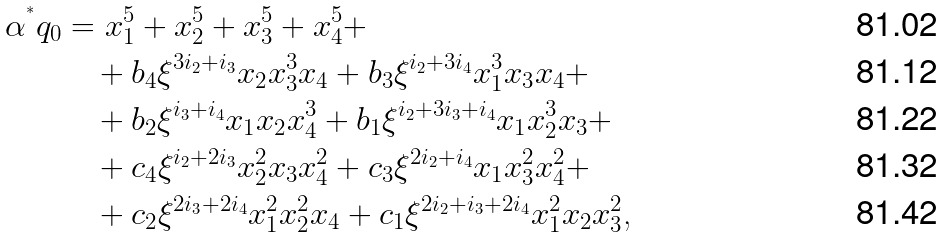Convert formula to latex. <formula><loc_0><loc_0><loc_500><loc_500>\alpha ^ { ^ { * } } q _ { 0 } & = x _ { 1 } ^ { 5 } + x _ { 2 } ^ { 5 } + x _ { 3 } ^ { 5 } + x _ { 4 } ^ { 5 } + \\ & \quad + b _ { 4 } \xi ^ { 3 i _ { 2 } + i _ { 3 } } x _ { 2 } x _ { 3 } ^ { 3 } x _ { 4 } + b _ { 3 } \xi ^ { i _ { 2 } + 3 i _ { 4 } } x _ { 1 } ^ { 3 } x _ { 3 } x _ { 4 } + \\ & \quad + b _ { 2 } \xi ^ { i _ { 3 } + i _ { 4 } } x _ { 1 } x _ { 2 } x _ { 4 } ^ { 3 } + b _ { 1 } \xi ^ { i _ { 2 } + 3 i _ { 3 } + i _ { 4 } } x _ { 1 } x _ { 2 } ^ { 3 } x _ { 3 } + \\ & \quad + c _ { 4 } \xi ^ { i _ { 2 } + 2 i _ { 3 } } x _ { 2 } ^ { 2 } x _ { 3 } x _ { 4 } ^ { 2 } + c _ { 3 } \xi ^ { 2 i _ { 2 } + i _ { 4 } } x _ { 1 } x _ { 3 } ^ { 2 } x _ { 4 } ^ { 2 } + \\ & \quad + c _ { 2 } \xi ^ { 2 i _ { 3 } + 2 i _ { 4 } } x _ { 1 } ^ { 2 } x _ { 2 } ^ { 2 } x _ { 4 } + c _ { 1 } \xi ^ { 2 i _ { 2 } + i _ { 3 } + 2 i _ { 4 } } x _ { 1 } ^ { 2 } x _ { 2 } x _ { 3 } ^ { 2 } \text {,}</formula> 